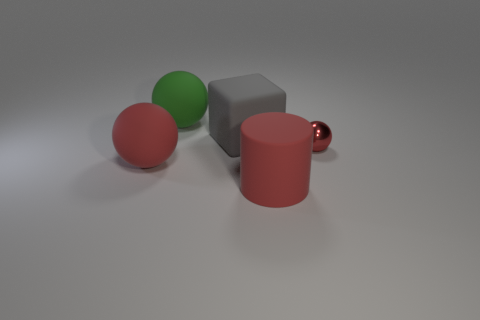There is a matte block behind the big red thing that is on the right side of the rubber ball that is to the left of the big green sphere; what is its color?
Make the answer very short. Gray. Is the ball behind the gray matte cube made of the same material as the large cylinder?
Give a very brief answer. Yes. What number of other things are there of the same material as the green sphere
Ensure brevity in your answer.  3. There is a cylinder that is the same size as the green object; what is it made of?
Ensure brevity in your answer.  Rubber. There is a small red thing in front of the large green object; is it the same shape as the large red rubber thing to the left of the big green sphere?
Your answer should be compact. Yes. What shape is the green matte thing that is the same size as the gray object?
Your response must be concise. Sphere. Is the material of the ball in front of the red metal sphere the same as the object behind the gray rubber thing?
Make the answer very short. Yes. There is a red thing that is right of the large red cylinder; is there a large ball that is on the right side of it?
Give a very brief answer. No. There is a big cube that is made of the same material as the large cylinder; what is its color?
Your response must be concise. Gray. Is the number of gray rubber blocks greater than the number of small blue metal cylinders?
Ensure brevity in your answer.  Yes. 